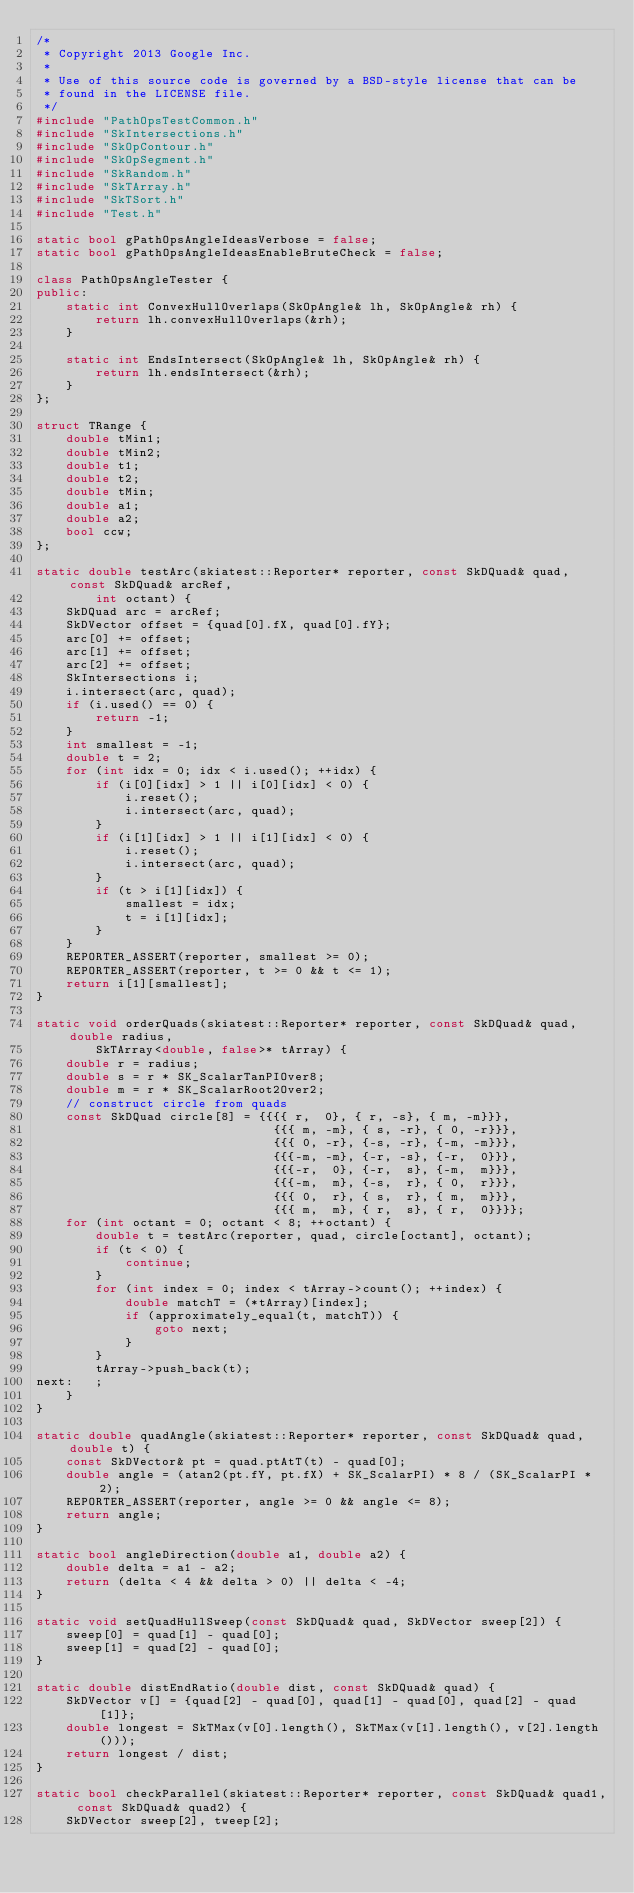<code> <loc_0><loc_0><loc_500><loc_500><_C++_>/*
 * Copyright 2013 Google Inc.
 *
 * Use of this source code is governed by a BSD-style license that can be
 * found in the LICENSE file.
 */
#include "PathOpsTestCommon.h"
#include "SkIntersections.h"
#include "SkOpContour.h"
#include "SkOpSegment.h"
#include "SkRandom.h"
#include "SkTArray.h"
#include "SkTSort.h"
#include "Test.h"

static bool gPathOpsAngleIdeasVerbose = false;
static bool gPathOpsAngleIdeasEnableBruteCheck = false;

class PathOpsAngleTester {
public:
    static int ConvexHullOverlaps(SkOpAngle& lh, SkOpAngle& rh) {
        return lh.convexHullOverlaps(&rh);
    }

    static int EndsIntersect(SkOpAngle& lh, SkOpAngle& rh) {
        return lh.endsIntersect(&rh);
    }
};

struct TRange {
    double tMin1;
    double tMin2;
    double t1;
    double t2;
    double tMin;
    double a1;
    double a2;
    bool ccw;
};

static double testArc(skiatest::Reporter* reporter, const SkDQuad& quad, const SkDQuad& arcRef,
        int octant) {
    SkDQuad arc = arcRef;
    SkDVector offset = {quad[0].fX, quad[0].fY};
    arc[0] += offset;
    arc[1] += offset;
    arc[2] += offset;
    SkIntersections i;
    i.intersect(arc, quad);
    if (i.used() == 0) {
        return -1;
    }
    int smallest = -1;
    double t = 2;
    for (int idx = 0; idx < i.used(); ++idx) {
        if (i[0][idx] > 1 || i[0][idx] < 0) {
            i.reset();
            i.intersect(arc, quad);
        }
        if (i[1][idx] > 1 || i[1][idx] < 0) {
            i.reset();
            i.intersect(arc, quad);
        }
        if (t > i[1][idx]) {
            smallest = idx;
            t = i[1][idx];
        }
    }
    REPORTER_ASSERT(reporter, smallest >= 0);
    REPORTER_ASSERT(reporter, t >= 0 && t <= 1);
    return i[1][smallest];
}

static void orderQuads(skiatest::Reporter* reporter, const SkDQuad& quad, double radius,
        SkTArray<double, false>* tArray) {
    double r = radius;
    double s = r * SK_ScalarTanPIOver8;
    double m = r * SK_ScalarRoot2Over2;
    // construct circle from quads
    const SkDQuad circle[8] = {{{{ r,  0}, { r, -s}, { m, -m}}},
                                {{{ m, -m}, { s, -r}, { 0, -r}}},
                                {{{ 0, -r}, {-s, -r}, {-m, -m}}},
                                {{{-m, -m}, {-r, -s}, {-r,  0}}},
                                {{{-r,  0}, {-r,  s}, {-m,  m}}},
                                {{{-m,  m}, {-s,  r}, { 0,  r}}},
                                {{{ 0,  r}, { s,  r}, { m,  m}}},
                                {{{ m,  m}, { r,  s}, { r,  0}}}};
    for (int octant = 0; octant < 8; ++octant) {
        double t = testArc(reporter, quad, circle[octant], octant);
        if (t < 0) {
            continue;
        }
        for (int index = 0; index < tArray->count(); ++index) {
            double matchT = (*tArray)[index];
            if (approximately_equal(t, matchT)) {
                goto next;
            }
        }
        tArray->push_back(t);
next:   ;
    }
}

static double quadAngle(skiatest::Reporter* reporter, const SkDQuad& quad, double t) {
    const SkDVector& pt = quad.ptAtT(t) - quad[0];
    double angle = (atan2(pt.fY, pt.fX) + SK_ScalarPI) * 8 / (SK_ScalarPI * 2);
    REPORTER_ASSERT(reporter, angle >= 0 && angle <= 8);
    return angle;
}

static bool angleDirection(double a1, double a2) {
    double delta = a1 - a2;
    return (delta < 4 && delta > 0) || delta < -4;
}

static void setQuadHullSweep(const SkDQuad& quad, SkDVector sweep[2]) {
    sweep[0] = quad[1] - quad[0];
    sweep[1] = quad[2] - quad[0];
}

static double distEndRatio(double dist, const SkDQuad& quad) {
    SkDVector v[] = {quad[2] - quad[0], quad[1] - quad[0], quad[2] - quad[1]};
    double longest = SkTMax(v[0].length(), SkTMax(v[1].length(), v[2].length()));
    return longest / dist;
}

static bool checkParallel(skiatest::Reporter* reporter, const SkDQuad& quad1, const SkDQuad& quad2) {
    SkDVector sweep[2], tweep[2];</code> 